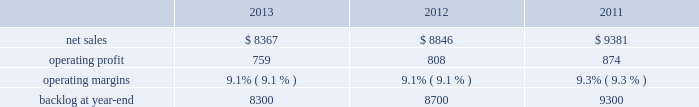Aeronautics 2019 operating profit for 2012 increased $ 69 million , or 4% ( 4 % ) , compared to 2011 .
The increase was attributable to higher operating profit of approximately $ 105 million from c-130 programs due to an increase in risk retirements ; about $ 50 million from f-16 programs due to higher aircraft deliveries partially offset by a decline in risk retirements ; approximately $ 50 million from f-35 production contracts due to increased production volume and risk retirements ; and about $ 50 million from the completion of purchased intangible asset amortization on certain f-16 contracts .
Partially offsetting the increases was lower operating profit of about $ 90 million from the f-35 development contract primarily due to the inception-to-date effect of reducing the profit booking rate in the second quarter of 2012 ; approximately $ 50 million from decreased production volume and risk retirements on the f-22 program partially offset by a resolution of a contractual matter in the second quarter of 2012 ; and approximately $ 45 million primarily due to a decrease in risk retirements on other sustainment activities partially offset by various other aeronautics programs due to increased risk retirements and volume .
Operating profit for c-5 programs was comparable to 2011 .
Adjustments not related to volume , including net profit booking rate adjustments and other matters described above , were approximately $ 30 million lower for 2012 compared to 2011 .
Backlog backlog decreased in 2013 compared to 2012 mainly due to lower orders on f-16 , c-5 , and c-130 programs , partially offset by higher orders on the f-35 program .
Backlog decreased in 2012 compared to 2011 mainly due to lower orders on f-35 and c-130 programs , partially offset by higher orders on f-16 programs .
Trends we expect aeronautics 2019 net sales to increase in 2014 in the mid-single digit percentage range as compared to 2013 primarily due to an increase in net sales from f-35 production contracts .
Operating profit is expected to increase slightly from 2013 , resulting in a slight decrease in operating margins between the years due to program mix .
Information systems & global solutions our is&gs business segment provides advanced technology systems and expertise , integrated information technology solutions , and management services across a broad spectrum of applications for civil , defense , intelligence , and other government customers .
Is&gs has a portfolio of many smaller contracts as compared to our other business segments .
Is&gs has been impacted by the continued downturn in federal information technology budgets .
Is&gs 2019 operating results included the following ( in millions ) : .
2013 compared to 2012 is&gs 2019 net sales decreased $ 479 million , or 5% ( 5 % ) , for 2013 compared to 2012 .
The decrease was attributable to lower net sales of about $ 495 million due to decreased volume on various programs ( command and control programs for classified customers , ngi , and eram programs ) ; and approximately $ 320 million due to the completion of certain programs ( such as total information processing support services , the transportation worker identification credential ( twic ) , and odin ) .
The decrease was partially offset by higher net sales of about $ 340 million due to the start-up of certain programs ( such as the disa gsm-o and the national science foundation antarctic support ) .
Is&gs 2019 operating profit decreased $ 49 million , or 6% ( 6 % ) , for 2013 compared to 2012 .
The decrease was primarily attributable to lower operating profit of about $ 55 million due to certain programs nearing the end of their lifecycles , partially offset by higher operating profit of approximately $ 15 million due to the start-up of certain programs .
Adjustments not related to volume , including net profit booking rate adjustments and other matters , were comparable for 2013 compared to 2012 compared to 2011 is&gs 2019 net sales for 2012 decreased $ 535 million , or 6% ( 6 % ) , compared to 2011 .
The decrease was attributable to lower net sales of approximately $ 485 million due to the substantial completion of various programs during 2011 ( primarily jtrs ; odin ; and u.k .
Census ) ; and about $ 255 million due to lower volume on numerous other programs ( primarily hanford; .
As part of the overall total decline in net sales what was the percent of the offsetting increase to the overall decrease in the sale? 
Computations: (340 / (495 + 320))
Answer: 0.41718. Aeronautics 2019 operating profit for 2012 increased $ 69 million , or 4% ( 4 % ) , compared to 2011 .
The increase was attributable to higher operating profit of approximately $ 105 million from c-130 programs due to an increase in risk retirements ; about $ 50 million from f-16 programs due to higher aircraft deliveries partially offset by a decline in risk retirements ; approximately $ 50 million from f-35 production contracts due to increased production volume and risk retirements ; and about $ 50 million from the completion of purchased intangible asset amortization on certain f-16 contracts .
Partially offsetting the increases was lower operating profit of about $ 90 million from the f-35 development contract primarily due to the inception-to-date effect of reducing the profit booking rate in the second quarter of 2012 ; approximately $ 50 million from decreased production volume and risk retirements on the f-22 program partially offset by a resolution of a contractual matter in the second quarter of 2012 ; and approximately $ 45 million primarily due to a decrease in risk retirements on other sustainment activities partially offset by various other aeronautics programs due to increased risk retirements and volume .
Operating profit for c-5 programs was comparable to 2011 .
Adjustments not related to volume , including net profit booking rate adjustments and other matters described above , were approximately $ 30 million lower for 2012 compared to 2011 .
Backlog backlog decreased in 2013 compared to 2012 mainly due to lower orders on f-16 , c-5 , and c-130 programs , partially offset by higher orders on the f-35 program .
Backlog decreased in 2012 compared to 2011 mainly due to lower orders on f-35 and c-130 programs , partially offset by higher orders on f-16 programs .
Trends we expect aeronautics 2019 net sales to increase in 2014 in the mid-single digit percentage range as compared to 2013 primarily due to an increase in net sales from f-35 production contracts .
Operating profit is expected to increase slightly from 2013 , resulting in a slight decrease in operating margins between the years due to program mix .
Information systems & global solutions our is&gs business segment provides advanced technology systems and expertise , integrated information technology solutions , and management services across a broad spectrum of applications for civil , defense , intelligence , and other government customers .
Is&gs has a portfolio of many smaller contracts as compared to our other business segments .
Is&gs has been impacted by the continued downturn in federal information technology budgets .
Is&gs 2019 operating results included the following ( in millions ) : .
2013 compared to 2012 is&gs 2019 net sales decreased $ 479 million , or 5% ( 5 % ) , for 2013 compared to 2012 .
The decrease was attributable to lower net sales of about $ 495 million due to decreased volume on various programs ( command and control programs for classified customers , ngi , and eram programs ) ; and approximately $ 320 million due to the completion of certain programs ( such as total information processing support services , the transportation worker identification credential ( twic ) , and odin ) .
The decrease was partially offset by higher net sales of about $ 340 million due to the start-up of certain programs ( such as the disa gsm-o and the national science foundation antarctic support ) .
Is&gs 2019 operating profit decreased $ 49 million , or 6% ( 6 % ) , for 2013 compared to 2012 .
The decrease was primarily attributable to lower operating profit of about $ 55 million due to certain programs nearing the end of their lifecycles , partially offset by higher operating profit of approximately $ 15 million due to the start-up of certain programs .
Adjustments not related to volume , including net profit booking rate adjustments and other matters , were comparable for 2013 compared to 2012 compared to 2011 is&gs 2019 net sales for 2012 decreased $ 535 million , or 6% ( 6 % ) , compared to 2011 .
The decrease was attributable to lower net sales of approximately $ 485 million due to the substantial completion of various programs during 2011 ( primarily jtrs ; odin ; and u.k .
Census ) ; and about $ 255 million due to lower volume on numerous other programs ( primarily hanford; .
What were average operating profit for is&gs from 2011 to 2013 , in millions? 
Computations: table_average(operating profit, none)
Answer: 813.66667. 